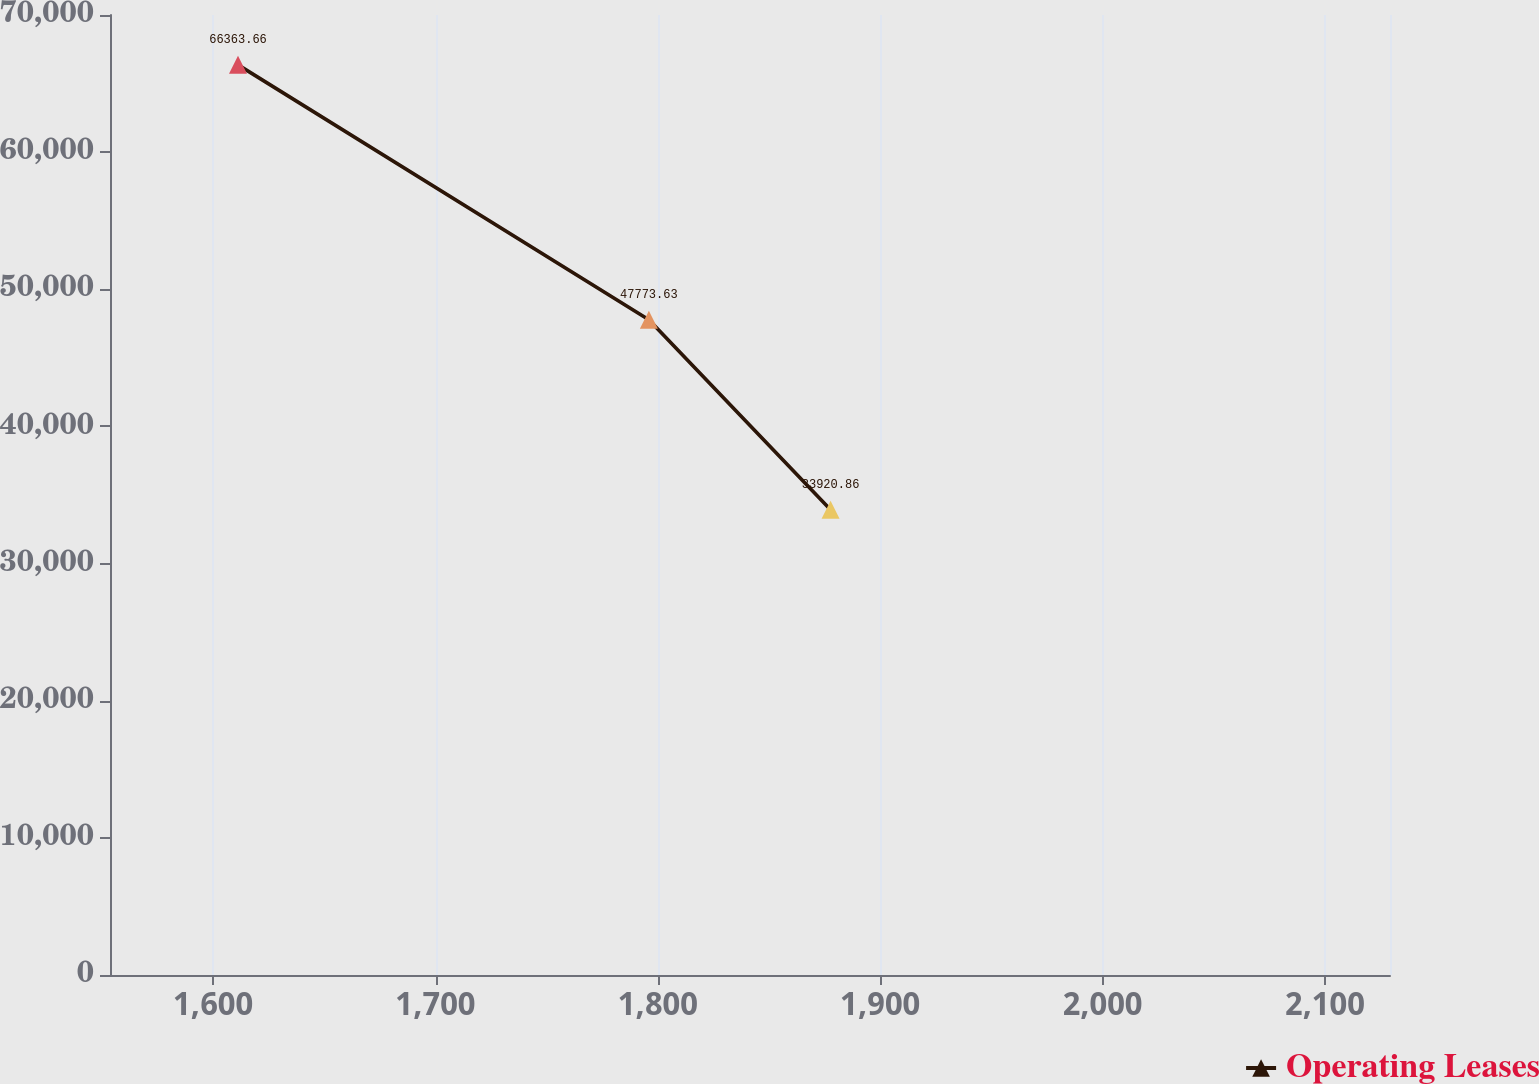<chart> <loc_0><loc_0><loc_500><loc_500><line_chart><ecel><fcel>Operating Leases<nl><fcel>1611.18<fcel>66363.7<nl><fcel>1795.95<fcel>47773.6<nl><fcel>1877.66<fcel>33920.9<nl><fcel>2133.09<fcel>12543.1<nl><fcel>2186.81<fcel>1253.04<nl></chart> 